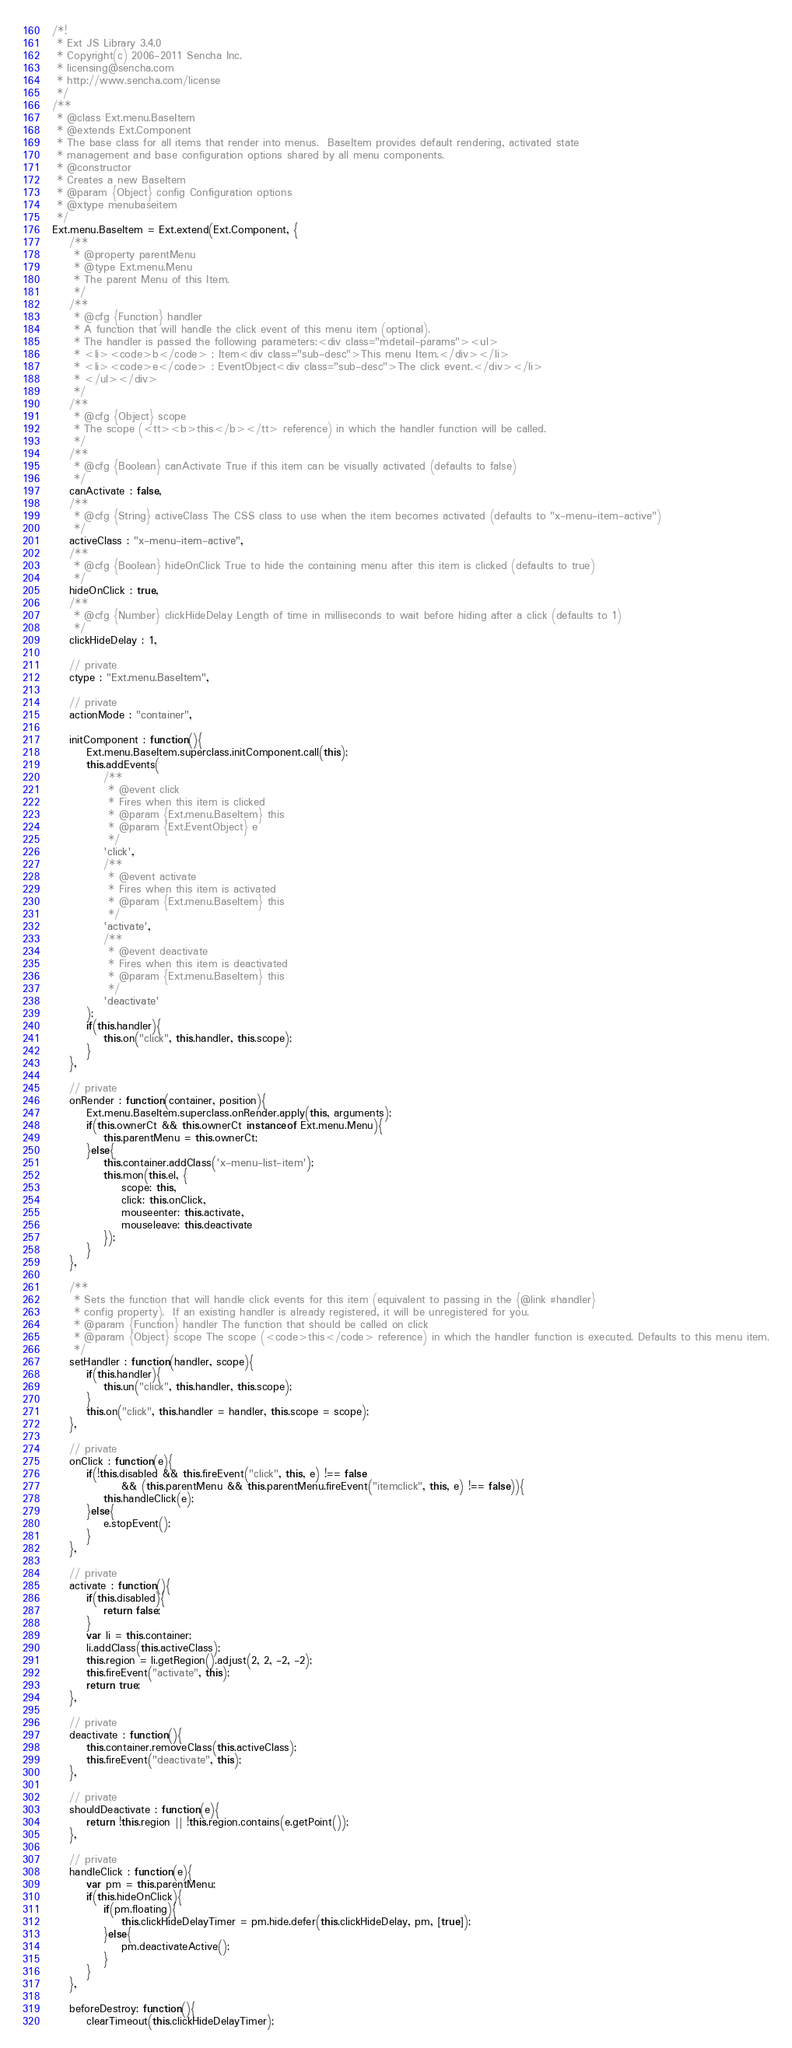Convert code to text. <code><loc_0><loc_0><loc_500><loc_500><_JavaScript_>/*!
 * Ext JS Library 3.4.0
 * Copyright(c) 2006-2011 Sencha Inc.
 * licensing@sencha.com
 * http://www.sencha.com/license
 */
/**
 * @class Ext.menu.BaseItem
 * @extends Ext.Component
 * The base class for all items that render into menus.  BaseItem provides default rendering, activated state
 * management and base configuration options shared by all menu components.
 * @constructor
 * Creates a new BaseItem
 * @param {Object} config Configuration options
 * @xtype menubaseitem
 */
Ext.menu.BaseItem = Ext.extend(Ext.Component, {
    /**
     * @property parentMenu
     * @type Ext.menu.Menu
     * The parent Menu of this Item.
     */
    /**
     * @cfg {Function} handler
     * A function that will handle the click event of this menu item (optional).
     * The handler is passed the following parameters:<div class="mdetail-params"><ul>
     * <li><code>b</code> : Item<div class="sub-desc">This menu Item.</div></li>
     * <li><code>e</code> : EventObject<div class="sub-desc">The click event.</div></li>
     * </ul></div>
     */
    /**
     * @cfg {Object} scope
     * The scope (<tt><b>this</b></tt> reference) in which the handler function will be called.
     */
    /**
     * @cfg {Boolean} canActivate True if this item can be visually activated (defaults to false)
     */
    canActivate : false,
    /**
     * @cfg {String} activeClass The CSS class to use when the item becomes activated (defaults to "x-menu-item-active")
     */
    activeClass : "x-menu-item-active",
    /**
     * @cfg {Boolean} hideOnClick True to hide the containing menu after this item is clicked (defaults to true)
     */
    hideOnClick : true,
    /**
     * @cfg {Number} clickHideDelay Length of time in milliseconds to wait before hiding after a click (defaults to 1)
     */
    clickHideDelay : 1,

    // private
    ctype : "Ext.menu.BaseItem",

    // private
    actionMode : "container",

    initComponent : function(){
        Ext.menu.BaseItem.superclass.initComponent.call(this);
        this.addEvents(
            /**
             * @event click
             * Fires when this item is clicked
             * @param {Ext.menu.BaseItem} this
             * @param {Ext.EventObject} e
             */
            'click',
            /**
             * @event activate
             * Fires when this item is activated
             * @param {Ext.menu.BaseItem} this
             */
            'activate',
            /**
             * @event deactivate
             * Fires when this item is deactivated
             * @param {Ext.menu.BaseItem} this
             */
            'deactivate'
        );
        if(this.handler){
            this.on("click", this.handler, this.scope);
        }
    },

    // private
    onRender : function(container, position){
        Ext.menu.BaseItem.superclass.onRender.apply(this, arguments);
        if(this.ownerCt && this.ownerCt instanceof Ext.menu.Menu){
            this.parentMenu = this.ownerCt;
        }else{
            this.container.addClass('x-menu-list-item');
            this.mon(this.el, {
                scope: this,
                click: this.onClick,
                mouseenter: this.activate,
                mouseleave: this.deactivate
            });
        }
    },

    /**
     * Sets the function that will handle click events for this item (equivalent to passing in the {@link #handler}
     * config property).  If an existing handler is already registered, it will be unregistered for you.
     * @param {Function} handler The function that should be called on click
     * @param {Object} scope The scope (<code>this</code> reference) in which the handler function is executed. Defaults to this menu item.
     */
    setHandler : function(handler, scope){
        if(this.handler){
            this.un("click", this.handler, this.scope);
        }
        this.on("click", this.handler = handler, this.scope = scope);
    },

    // private
    onClick : function(e){
        if(!this.disabled && this.fireEvent("click", this, e) !== false
                && (this.parentMenu && this.parentMenu.fireEvent("itemclick", this, e) !== false)){
            this.handleClick(e);
        }else{
            e.stopEvent();
        }
    },

    // private
    activate : function(){
        if(this.disabled){
            return false;
        }
        var li = this.container;
        li.addClass(this.activeClass);
        this.region = li.getRegion().adjust(2, 2, -2, -2);
        this.fireEvent("activate", this);
        return true;
    },

    // private
    deactivate : function(){
        this.container.removeClass(this.activeClass);
        this.fireEvent("deactivate", this);
    },

    // private
    shouldDeactivate : function(e){
        return !this.region || !this.region.contains(e.getPoint());
    },

    // private
    handleClick : function(e){
        var pm = this.parentMenu;
        if(this.hideOnClick){
            if(pm.floating){
                this.clickHideDelayTimer = pm.hide.defer(this.clickHideDelay, pm, [true]);
            }else{
                pm.deactivateActive();
            }
        }
    },
    
    beforeDestroy: function(){
        clearTimeout(this.clickHideDelayTimer);</code> 